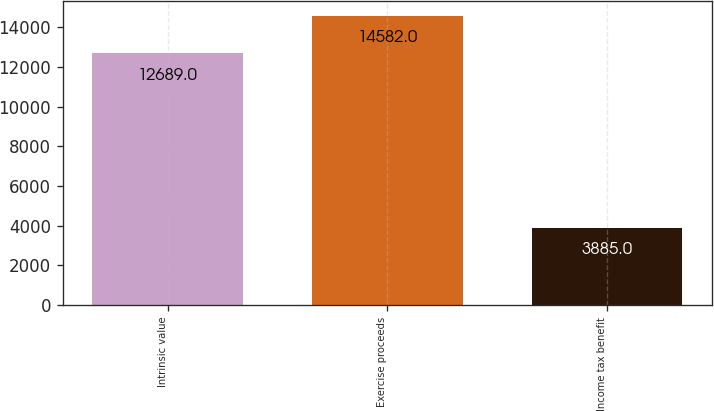Convert chart. <chart><loc_0><loc_0><loc_500><loc_500><bar_chart><fcel>Intrinsic value<fcel>Exercise proceeds<fcel>Income tax benefit<nl><fcel>12689<fcel>14582<fcel>3885<nl></chart> 